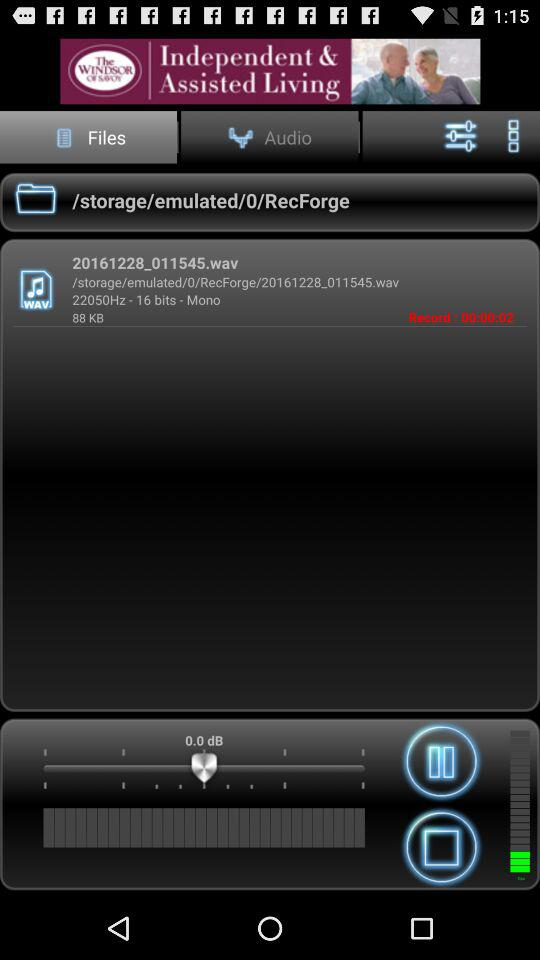Which tab has been selected? The tab that has been selected is "Files". 